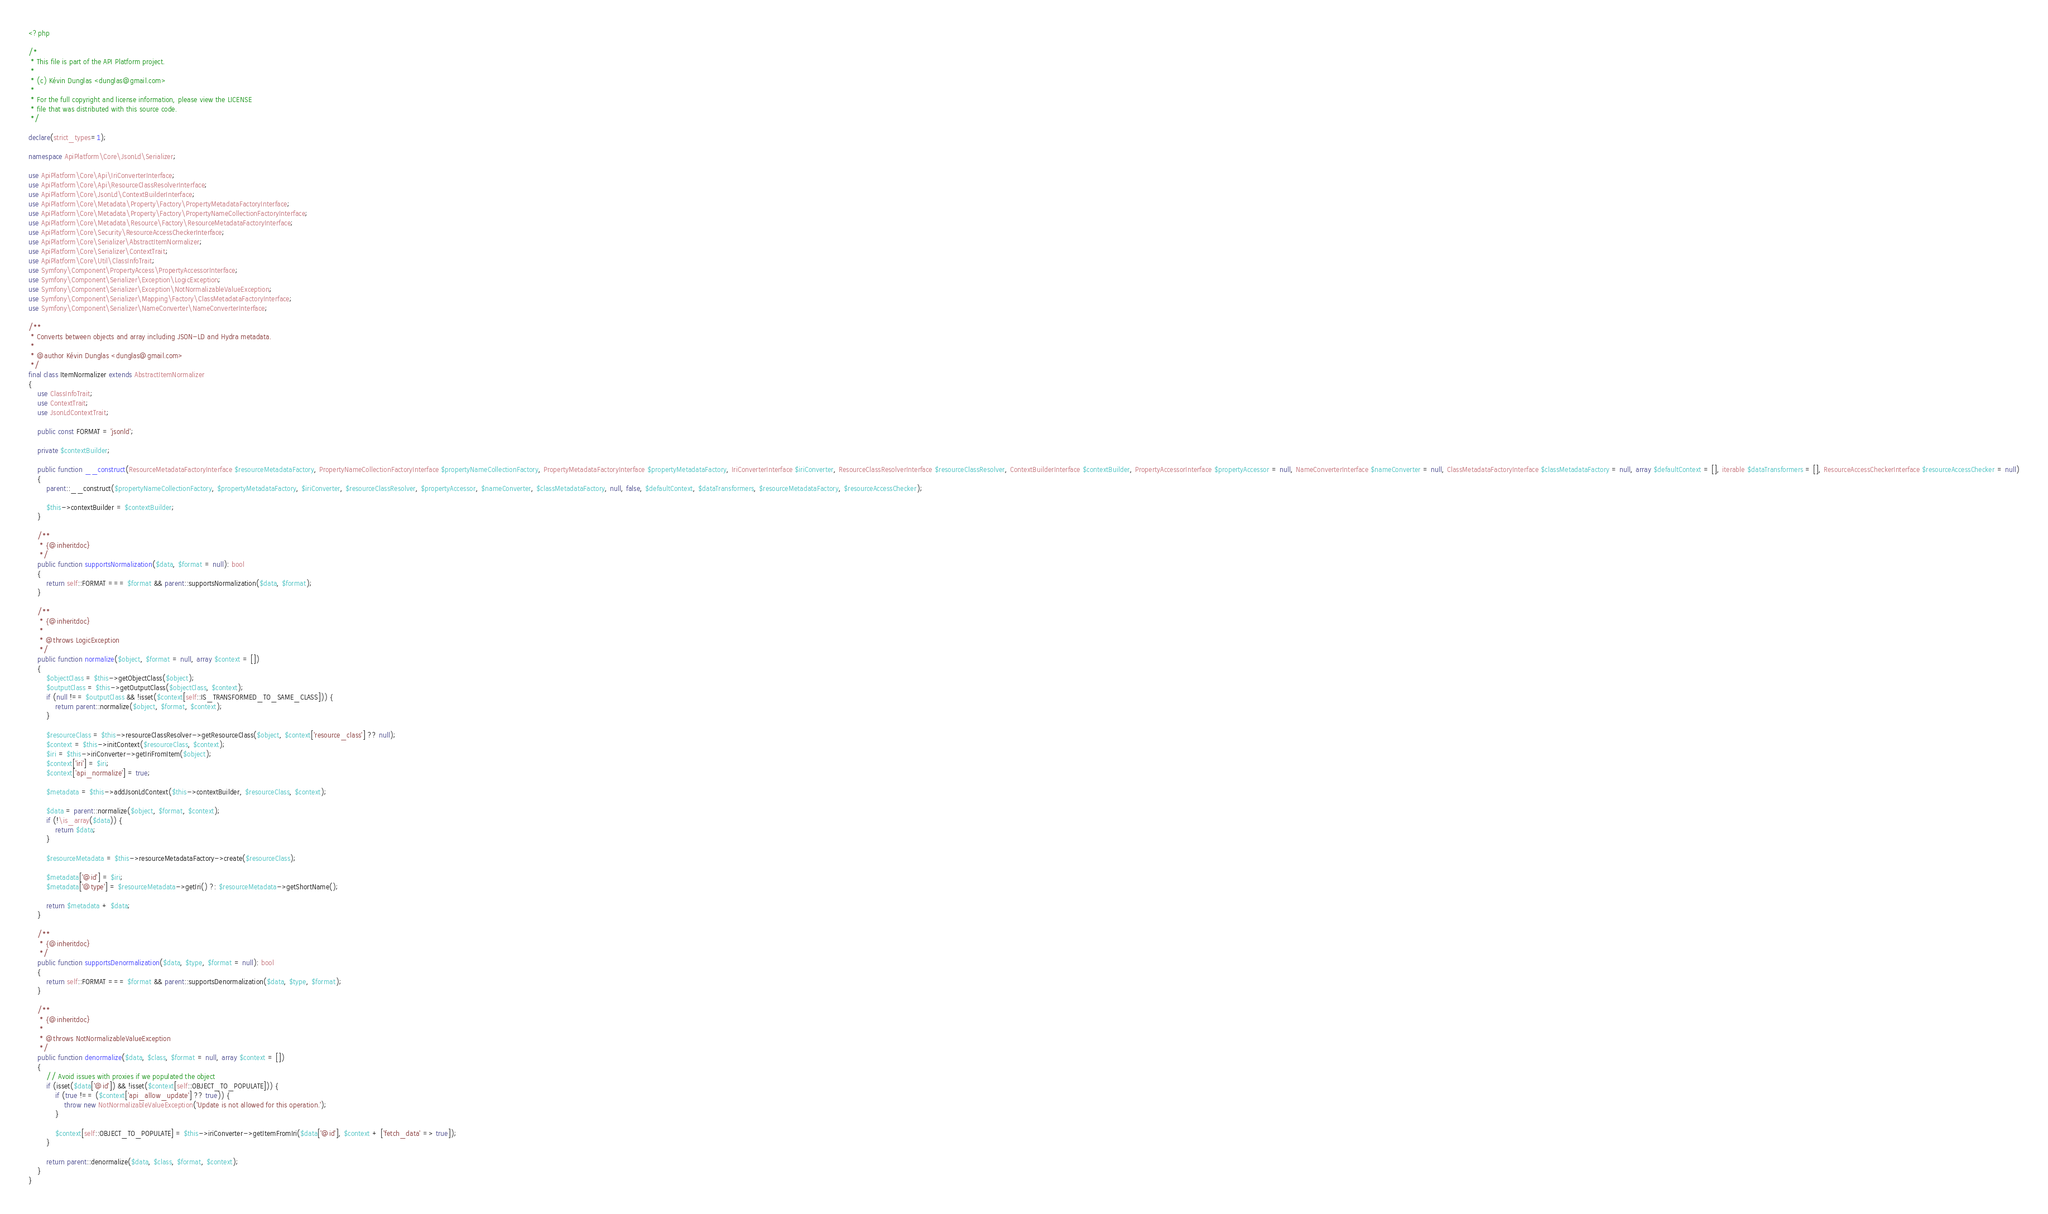Convert code to text. <code><loc_0><loc_0><loc_500><loc_500><_PHP_><?php

/*
 * This file is part of the API Platform project.
 *
 * (c) Kévin Dunglas <dunglas@gmail.com>
 *
 * For the full copyright and license information, please view the LICENSE
 * file that was distributed with this source code.
 */

declare(strict_types=1);

namespace ApiPlatform\Core\JsonLd\Serializer;

use ApiPlatform\Core\Api\IriConverterInterface;
use ApiPlatform\Core\Api\ResourceClassResolverInterface;
use ApiPlatform\Core\JsonLd\ContextBuilderInterface;
use ApiPlatform\Core\Metadata\Property\Factory\PropertyMetadataFactoryInterface;
use ApiPlatform\Core\Metadata\Property\Factory\PropertyNameCollectionFactoryInterface;
use ApiPlatform\Core\Metadata\Resource\Factory\ResourceMetadataFactoryInterface;
use ApiPlatform\Core\Security\ResourceAccessCheckerInterface;
use ApiPlatform\Core\Serializer\AbstractItemNormalizer;
use ApiPlatform\Core\Serializer\ContextTrait;
use ApiPlatform\Core\Util\ClassInfoTrait;
use Symfony\Component\PropertyAccess\PropertyAccessorInterface;
use Symfony\Component\Serializer\Exception\LogicException;
use Symfony\Component\Serializer\Exception\NotNormalizableValueException;
use Symfony\Component\Serializer\Mapping\Factory\ClassMetadataFactoryInterface;
use Symfony\Component\Serializer\NameConverter\NameConverterInterface;

/**
 * Converts between objects and array including JSON-LD and Hydra metadata.
 *
 * @author Kévin Dunglas <dunglas@gmail.com>
 */
final class ItemNormalizer extends AbstractItemNormalizer
{
    use ClassInfoTrait;
    use ContextTrait;
    use JsonLdContextTrait;

    public const FORMAT = 'jsonld';

    private $contextBuilder;

    public function __construct(ResourceMetadataFactoryInterface $resourceMetadataFactory, PropertyNameCollectionFactoryInterface $propertyNameCollectionFactory, PropertyMetadataFactoryInterface $propertyMetadataFactory, IriConverterInterface $iriConverter, ResourceClassResolverInterface $resourceClassResolver, ContextBuilderInterface $contextBuilder, PropertyAccessorInterface $propertyAccessor = null, NameConverterInterface $nameConverter = null, ClassMetadataFactoryInterface $classMetadataFactory = null, array $defaultContext = [], iterable $dataTransformers = [], ResourceAccessCheckerInterface $resourceAccessChecker = null)
    {
        parent::__construct($propertyNameCollectionFactory, $propertyMetadataFactory, $iriConverter, $resourceClassResolver, $propertyAccessor, $nameConverter, $classMetadataFactory, null, false, $defaultContext, $dataTransformers, $resourceMetadataFactory, $resourceAccessChecker);

        $this->contextBuilder = $contextBuilder;
    }

    /**
     * {@inheritdoc}
     */
    public function supportsNormalization($data, $format = null): bool
    {
        return self::FORMAT === $format && parent::supportsNormalization($data, $format);
    }

    /**
     * {@inheritdoc}
     *
     * @throws LogicException
     */
    public function normalize($object, $format = null, array $context = [])
    {
        $objectClass = $this->getObjectClass($object);
        $outputClass = $this->getOutputClass($objectClass, $context);
        if (null !== $outputClass && !isset($context[self::IS_TRANSFORMED_TO_SAME_CLASS])) {
            return parent::normalize($object, $format, $context);
        }

        $resourceClass = $this->resourceClassResolver->getResourceClass($object, $context['resource_class'] ?? null);
        $context = $this->initContext($resourceClass, $context);
        $iri = $this->iriConverter->getIriFromItem($object);
        $context['iri'] = $iri;
        $context['api_normalize'] = true;

        $metadata = $this->addJsonLdContext($this->contextBuilder, $resourceClass, $context);

        $data = parent::normalize($object, $format, $context);
        if (!\is_array($data)) {
            return $data;
        }

        $resourceMetadata = $this->resourceMetadataFactory->create($resourceClass);

        $metadata['@id'] = $iri;
        $metadata['@type'] = $resourceMetadata->getIri() ?: $resourceMetadata->getShortName();

        return $metadata + $data;
    }

    /**
     * {@inheritdoc}
     */
    public function supportsDenormalization($data, $type, $format = null): bool
    {
        return self::FORMAT === $format && parent::supportsDenormalization($data, $type, $format);
    }

    /**
     * {@inheritdoc}
     *
     * @throws NotNormalizableValueException
     */
    public function denormalize($data, $class, $format = null, array $context = [])
    {
        // Avoid issues with proxies if we populated the object
        if (isset($data['@id']) && !isset($context[self::OBJECT_TO_POPULATE])) {
            if (true !== ($context['api_allow_update'] ?? true)) {
                throw new NotNormalizableValueException('Update is not allowed for this operation.');
            }

            $context[self::OBJECT_TO_POPULATE] = $this->iriConverter->getItemFromIri($data['@id'], $context + ['fetch_data' => true]);
        }

        return parent::denormalize($data, $class, $format, $context);
    }
}
</code> 